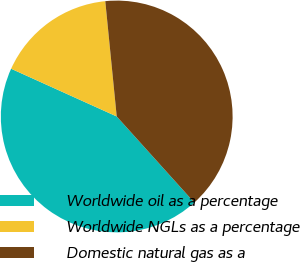<chart> <loc_0><loc_0><loc_500><loc_500><pie_chart><fcel>Worldwide oil as a percentage<fcel>Worldwide NGLs as a percentage<fcel>Domestic natural gas as a<nl><fcel>43.43%<fcel>16.67%<fcel>39.9%<nl></chart> 